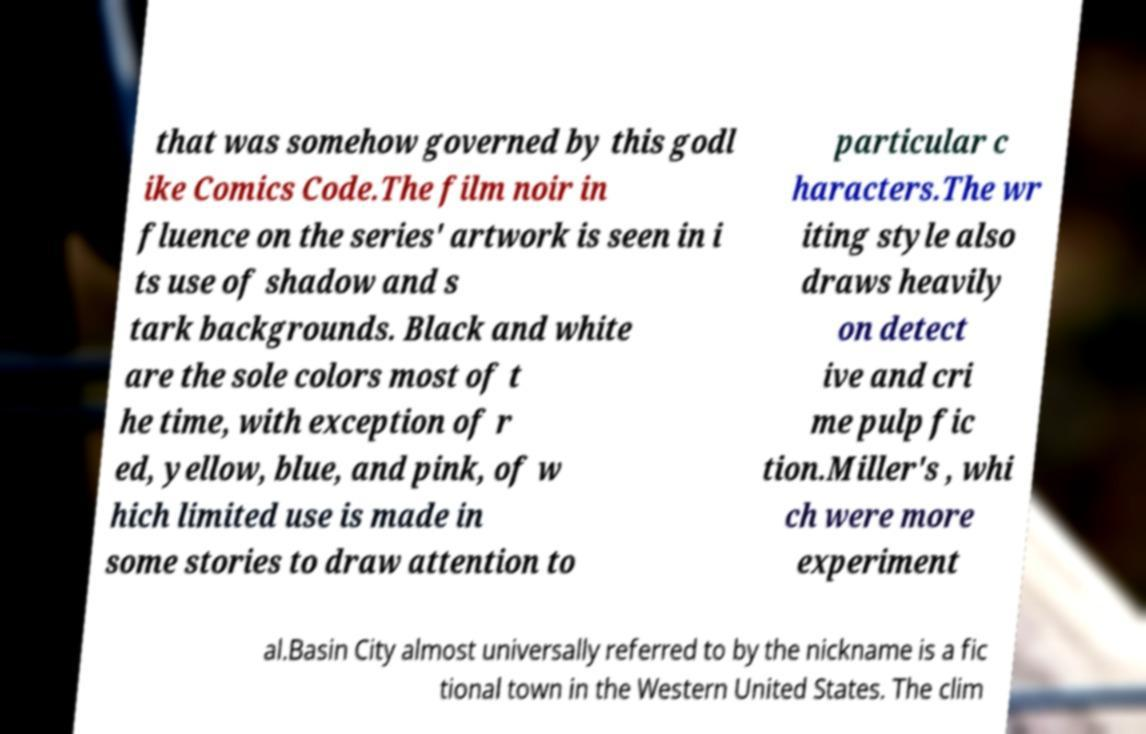I need the written content from this picture converted into text. Can you do that? that was somehow governed by this godl ike Comics Code.The film noir in fluence on the series' artwork is seen in i ts use of shadow and s tark backgrounds. Black and white are the sole colors most of t he time, with exception of r ed, yellow, blue, and pink, of w hich limited use is made in some stories to draw attention to particular c haracters.The wr iting style also draws heavily on detect ive and cri me pulp fic tion.Miller's , whi ch were more experiment al.Basin City almost universally referred to by the nickname is a fic tional town in the Western United States. The clim 